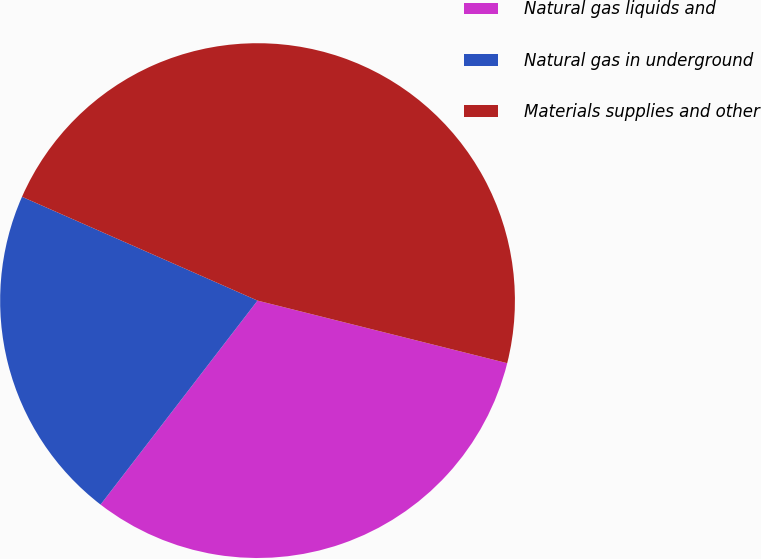<chart> <loc_0><loc_0><loc_500><loc_500><pie_chart><fcel>Natural gas liquids and<fcel>Natural gas in underground<fcel>Materials supplies and other<nl><fcel>31.53%<fcel>21.17%<fcel>47.3%<nl></chart> 